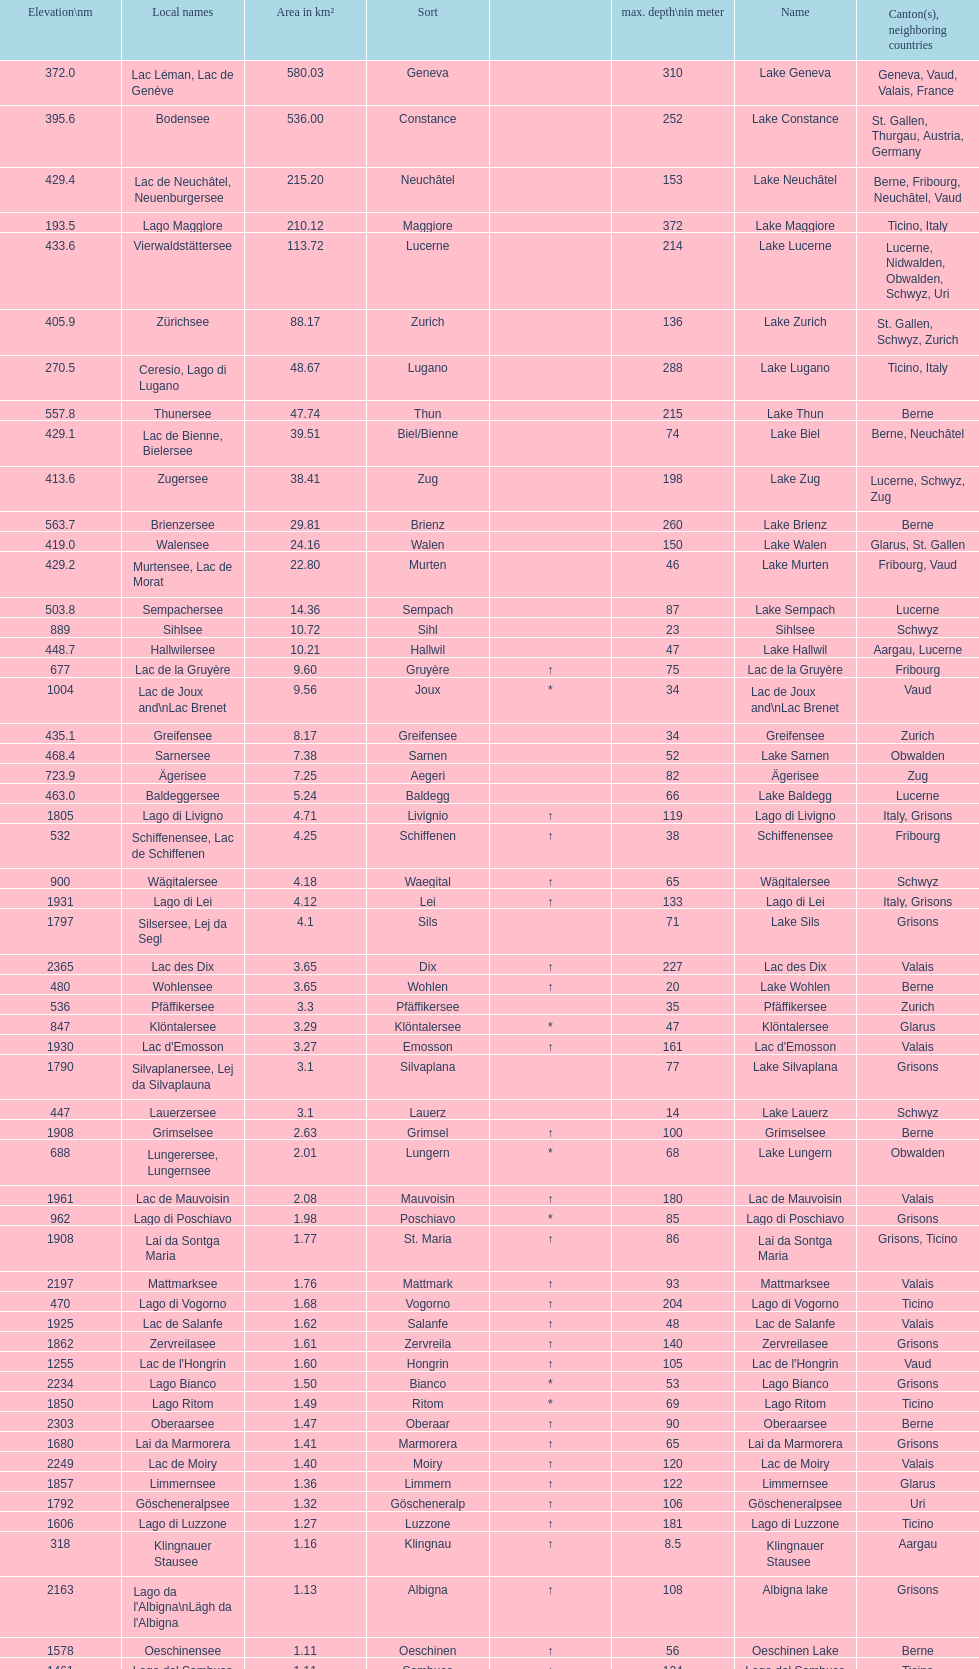Identify the sole lake that reaches a depth of 372 meters at its deepest point. Lake Maggiore. Parse the table in full. {'header': ['Elevation\\nm', 'Local names', 'Area in km²', 'Sort', '', 'max. depth\\nin meter', 'Name', 'Canton(s), neighboring countries'], 'rows': [['372.0', 'Lac Léman, Lac de Genève', '580.03', 'Geneva', '', '310', 'Lake Geneva', 'Geneva, Vaud, Valais, France'], ['395.6', 'Bodensee', '536.00', 'Constance', '', '252', 'Lake Constance', 'St. Gallen, Thurgau, Austria, Germany'], ['429.4', 'Lac de Neuchâtel, Neuenburgersee', '215.20', 'Neuchâtel', '', '153', 'Lake Neuchâtel', 'Berne, Fribourg, Neuchâtel, Vaud'], ['193.5', 'Lago Maggiore', '210.12', 'Maggiore', '', '372', 'Lake Maggiore', 'Ticino, Italy'], ['433.6', 'Vierwaldstättersee', '113.72', 'Lucerne', '', '214', 'Lake Lucerne', 'Lucerne, Nidwalden, Obwalden, Schwyz, Uri'], ['405.9', 'Zürichsee', '88.17', 'Zurich', '', '136', 'Lake Zurich', 'St. Gallen, Schwyz, Zurich'], ['270.5', 'Ceresio, Lago di Lugano', '48.67', 'Lugano', '', '288', 'Lake Lugano', 'Ticino, Italy'], ['557.8', 'Thunersee', '47.74', 'Thun', '', '215', 'Lake Thun', 'Berne'], ['429.1', 'Lac de Bienne, Bielersee', '39.51', 'Biel/Bienne', '', '74', 'Lake Biel', 'Berne, Neuchâtel'], ['413.6', 'Zugersee', '38.41', 'Zug', '', '198', 'Lake Zug', 'Lucerne, Schwyz, Zug'], ['563.7', 'Brienzersee', '29.81', 'Brienz', '', '260', 'Lake Brienz', 'Berne'], ['419.0', 'Walensee', '24.16', 'Walen', '', '150', 'Lake Walen', 'Glarus, St. Gallen'], ['429.2', 'Murtensee, Lac de Morat', '22.80', 'Murten', '', '46', 'Lake Murten', 'Fribourg, Vaud'], ['503.8', 'Sempachersee', '14.36', 'Sempach', '', '87', 'Lake Sempach', 'Lucerne'], ['889', 'Sihlsee', '10.72', 'Sihl', '', '23', 'Sihlsee', 'Schwyz'], ['448.7', 'Hallwilersee', '10.21', 'Hallwil', '', '47', 'Lake Hallwil', 'Aargau, Lucerne'], ['677', 'Lac de la Gruyère', '9.60', 'Gruyère', '↑', '75', 'Lac de la Gruyère', 'Fribourg'], ['1004', 'Lac de Joux and\\nLac Brenet', '9.56', 'Joux', '*', '34', 'Lac de Joux and\\nLac Brenet', 'Vaud'], ['435.1', 'Greifensee', '8.17', 'Greifensee', '', '34', 'Greifensee', 'Zurich'], ['468.4', 'Sarnersee', '7.38', 'Sarnen', '', '52', 'Lake Sarnen', 'Obwalden'], ['723.9', 'Ägerisee', '7.25', 'Aegeri', '', '82', 'Ägerisee', 'Zug'], ['463.0', 'Baldeggersee', '5.24', 'Baldegg', '', '66', 'Lake Baldegg', 'Lucerne'], ['1805', 'Lago di Livigno', '4.71', 'Livignio', '↑', '119', 'Lago di Livigno', 'Italy, Grisons'], ['532', 'Schiffenensee, Lac de Schiffenen', '4.25', 'Schiffenen', '↑', '38', 'Schiffenensee', 'Fribourg'], ['900', 'Wägitalersee', '4.18', 'Waegital', '↑', '65', 'Wägitalersee', 'Schwyz'], ['1931', 'Lago di Lei', '4.12', 'Lei', '↑', '133', 'Lago di Lei', 'Italy, Grisons'], ['1797', 'Silsersee, Lej da Segl', '4.1', 'Sils', '', '71', 'Lake Sils', 'Grisons'], ['2365', 'Lac des Dix', '3.65', 'Dix', '↑', '227', 'Lac des Dix', 'Valais'], ['480', 'Wohlensee', '3.65', 'Wohlen', '↑', '20', 'Lake Wohlen', 'Berne'], ['536', 'Pfäffikersee', '3.3', 'Pfäffikersee', '', '35', 'Pfäffikersee', 'Zurich'], ['847', 'Klöntalersee', '3.29', 'Klöntalersee', '*', '47', 'Klöntalersee', 'Glarus'], ['1930', "Lac d'Emosson", '3.27', 'Emosson', '↑', '161', "Lac d'Emosson", 'Valais'], ['1790', 'Silvaplanersee, Lej da Silvaplauna', '3.1', 'Silvaplana', '', '77', 'Lake Silvaplana', 'Grisons'], ['447', 'Lauerzersee', '3.1', 'Lauerz', '', '14', 'Lake Lauerz', 'Schwyz'], ['1908', 'Grimselsee', '2.63', 'Grimsel', '↑', '100', 'Grimselsee', 'Berne'], ['688', 'Lungerersee, Lungernsee', '2.01', 'Lungern', '*', '68', 'Lake Lungern', 'Obwalden'], ['1961', 'Lac de Mauvoisin', '2.08', 'Mauvoisin', '↑', '180', 'Lac de Mauvoisin', 'Valais'], ['962', 'Lago di Poschiavo', '1.98', 'Poschiavo', '*', '85', 'Lago di Poschiavo', 'Grisons'], ['1908', 'Lai da Sontga Maria', '1.77', 'St. Maria', '↑', '86', 'Lai da Sontga Maria', 'Grisons, Ticino'], ['2197', 'Mattmarksee', '1.76', 'Mattmark', '↑', '93', 'Mattmarksee', 'Valais'], ['470', 'Lago di Vogorno', '1.68', 'Vogorno', '↑', '204', 'Lago di Vogorno', 'Ticino'], ['1925', 'Lac de Salanfe', '1.62', 'Salanfe', '↑', '48', 'Lac de Salanfe', 'Valais'], ['1862', 'Zervreilasee', '1.61', 'Zervreila', '↑', '140', 'Zervreilasee', 'Grisons'], ['1255', "Lac de l'Hongrin", '1.60', 'Hongrin', '↑', '105', "Lac de l'Hongrin", 'Vaud'], ['2234', 'Lago Bianco', '1.50', 'Bianco', '*', '53', 'Lago Bianco', 'Grisons'], ['1850', 'Lago Ritom', '1.49', 'Ritom', '*', '69', 'Lago Ritom', 'Ticino'], ['2303', 'Oberaarsee', '1.47', 'Oberaar', '↑', '90', 'Oberaarsee', 'Berne'], ['1680', 'Lai da Marmorera', '1.41', 'Marmorera', '↑', '65', 'Lai da Marmorera', 'Grisons'], ['2249', 'Lac de Moiry', '1.40', 'Moiry', '↑', '120', 'Lac de Moiry', 'Valais'], ['1857', 'Limmernsee', '1.36', 'Limmern', '↑', '122', 'Limmernsee', 'Glarus'], ['1792', 'Göscheneralpsee', '1.32', 'Göscheneralp', '↑', '106', 'Göscheneralpsee', 'Uri'], ['1606', 'Lago di Luzzone', '1.27', 'Luzzone', '↑', '181', 'Lago di Luzzone', 'Ticino'], ['318', 'Klingnauer Stausee', '1.16', 'Klingnau', '↑', '8.5', 'Klingnauer Stausee', 'Aargau'], ['2163', "Lago da l'Albigna\\nLägh da l'Albigna", '1.13', 'Albigna', '↑', '108', 'Albigna lake', 'Grisons'], ['1578', 'Oeschinensee', '1.11', 'Oeschinen', '↑', '56', 'Oeschinen Lake', 'Berne'], ['1461', 'Lago del Sambuco', '1.11', 'Sambuco', '↑', '124', 'Lago del Sambuco', 'Ticino']]} 